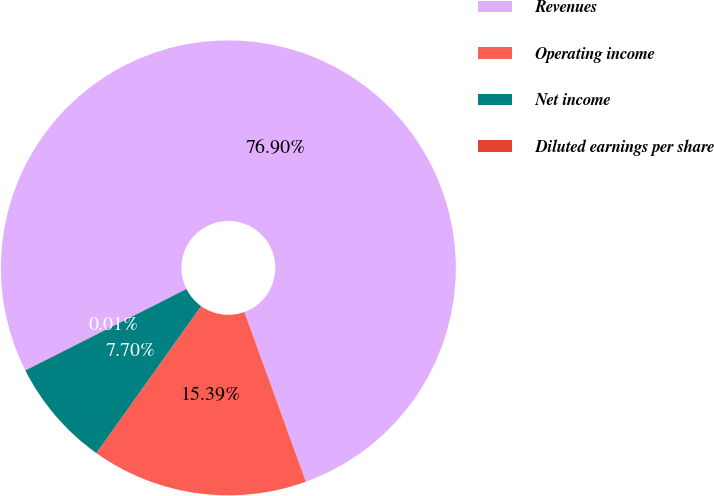Convert chart to OTSL. <chart><loc_0><loc_0><loc_500><loc_500><pie_chart><fcel>Revenues<fcel>Operating income<fcel>Net income<fcel>Diluted earnings per share<nl><fcel>76.91%<fcel>15.39%<fcel>7.7%<fcel>0.01%<nl></chart> 